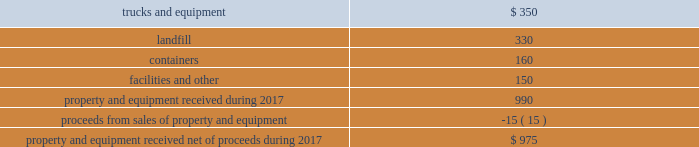We believe that the presentation of adjusted diluted earnings per share , which excludes withdrawal costs 2013 multiemployer pension funds , restructuring charges , loss on extinguishment of debt , and ( gain ) loss on business dispositions and impairments , net , provides an understanding of operational activities before the financial effect of certain items .
We use this measure , and believe investors will find it helpful , in understanding the ongoing performance of our operations separate from items that have a disproportionate effect on our results for a particular period .
We have incurred comparable charges and costs in prior periods , and similar types of adjustments can reasonably be expected to be recorded in future periods .
Our definition of adjusted diluted earnings per share may not be comparable to similarly titled measures presented by other companies .
Property and equipment , net in 2017 , we anticipate receiving approximately $ 975 million of property and equipment , net of proceeds from sales of property and equipment , as follows: .
Results of operations revenue we generate revenue primarily from our solid waste collection operations .
Our remaining revenue is from other services , including transfer station , landfill disposal , recycling , and energy services .
Our residential and small- container commercial collection operations in some markets are based on long-term contracts with municipalities .
Certain of our municipal contracts have annual price escalation clauses that are tied to changes in an underlying base index such as a consumer price index .
We generally provide small-container commercial and large-container industrial collection services to customers under contracts with terms up to three years .
Our transfer stations , landfills and , to a lesser extent , our recycling facilities generate revenue from disposal or tipping fees charged to third parties .
In general , we integrate our recycling operations with our collection operations and obtain revenue from the sale of recycled commodities .
Our revenue from energy services consists mainly of fees we charge for the treatment of liquid and solid waste derived from the production of oil and natural gas .
Other revenue consists primarily of revenue from national accounts , which represents the portion of revenue generated from nationwide or regional contracts in markets outside our operating areas where the associated waste handling services are subcontracted to local operators .
Consequently , substantially all of this revenue is offset with related subcontract costs , which are recorded in cost of operations. .
As part of the sales proceeds net what was the ratio of trucks and equipment to the containers? 
Rationale: there is 2.2 trucks and equipment for every container
Computations: (350 / 160)
Answer: 2.1875. 